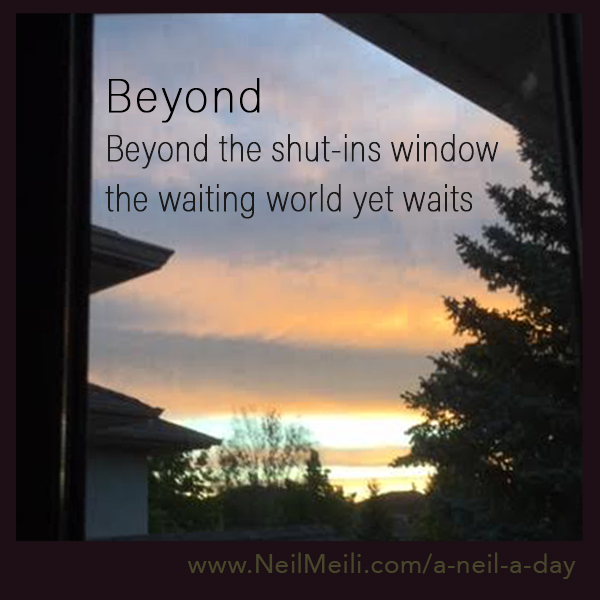Can you describe the mood this image evokes? The image evokes a peaceful and reflective mood. The warm colors of the sunset or sunrise combined with the contemplative text create a sense of calm and introspection, as if the viewer is encouraged to pause and ponder the beauty and stillness of the moment. 